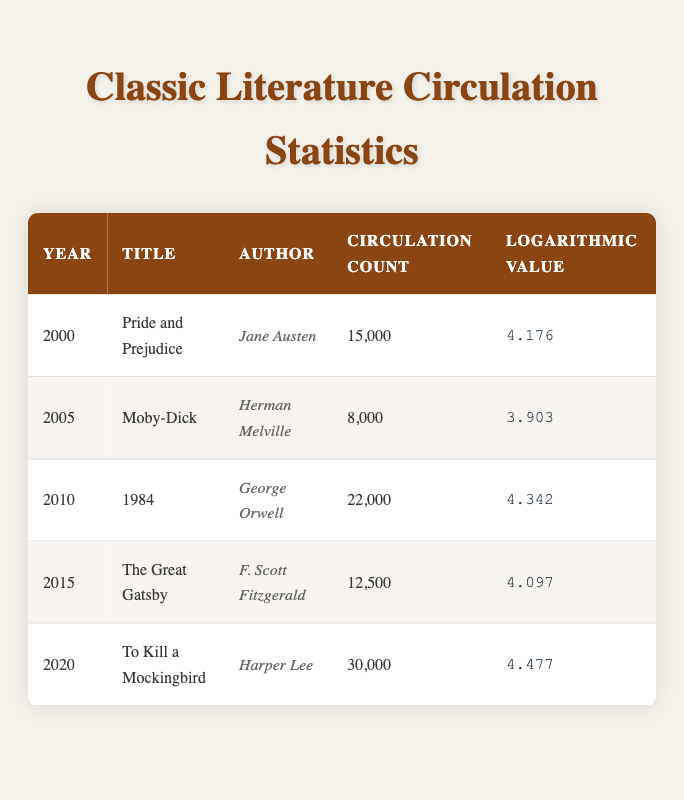What was the circulation count for "1984"? The table shows the data for "1984" in the row corresponding to the year 2010. The circulation count listed is 22,000.
Answer: 22,000 Which book had the highest circulation count between 2000 and 2020? By examining the circulation counts from each year in the table, "To Kill a Mockingbird" in 2020 had the highest circulation count of 30,000 compared to the other books.
Answer: To Kill a Mockingbird What is the average circulation count for the books listed from 2000 to 2020? To calculate the average, we sum the circulation counts: 15,000 + 8,000 + 22,000 + 12,500 + 30,000 = 87,500. There are 5 data points, so the average is 87,500 / 5 = 17,500.
Answer: 17,500 Is the logarithmic value for "The Great Gatsby" greater than that for "Moby-Dick"? The logarithmic value for "The Great Gatsby" is 4.097, while for "Moby-Dick" it is 3.903. Since 4.097 is greater than 3.903, the statement is true.
Answer: Yes How much more was the circulation count for "To Kill a Mockingbird" compared to "Pride and Prejudice"? The circulation count for "To Kill a Mockingbird" is 30,000 and for "Pride and Prejudice" is 15,000. To find the difference, we calculate 30,000 - 15,000 = 15,000.
Answer: 15,000 